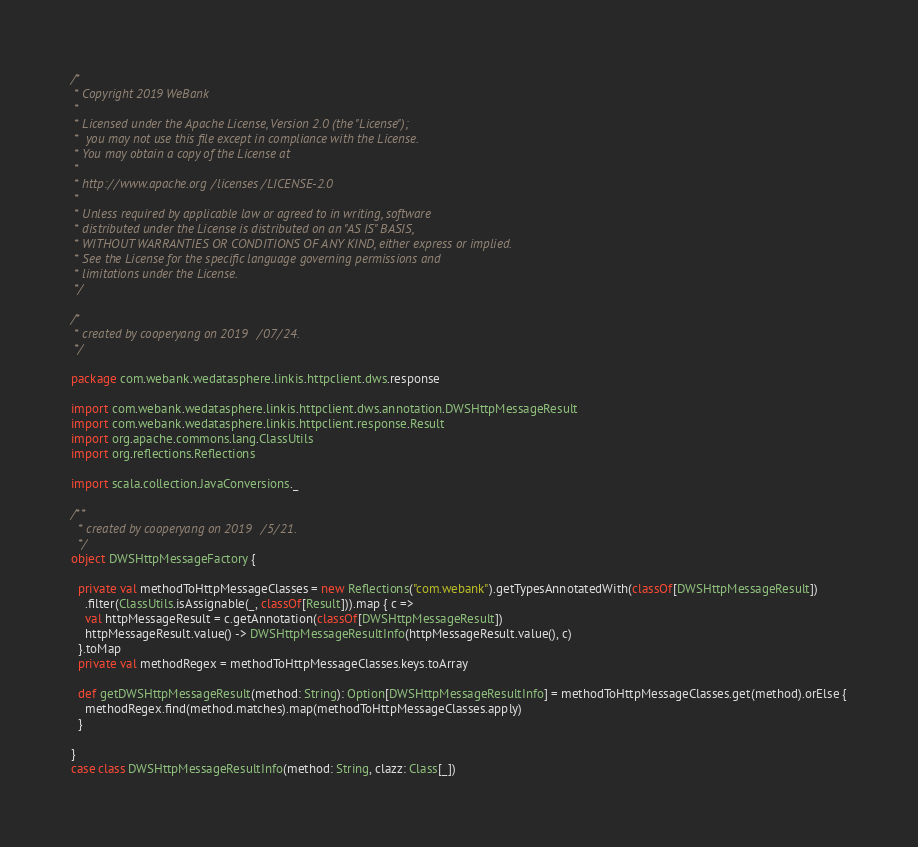<code> <loc_0><loc_0><loc_500><loc_500><_Scala_>/*
 * Copyright 2019 WeBank
 *
 * Licensed under the Apache License, Version 2.0 (the "License");
 *  you may not use this file except in compliance with the License.
 * You may obtain a copy of the License at
 *
 * http://www.apache.org/licenses/LICENSE-2.0
 *
 * Unless required by applicable law or agreed to in writing, software
 * distributed under the License is distributed on an "AS IS" BASIS,
 * WITHOUT WARRANTIES OR CONDITIONS OF ANY KIND, either express or implied.
 * See the License for the specific language governing permissions and
 * limitations under the License.
 */

/*
 * created by cooperyang on 2019/07/24.
 */

package com.webank.wedatasphere.linkis.httpclient.dws.response

import com.webank.wedatasphere.linkis.httpclient.dws.annotation.DWSHttpMessageResult
import com.webank.wedatasphere.linkis.httpclient.response.Result
import org.apache.commons.lang.ClassUtils
import org.reflections.Reflections

import scala.collection.JavaConversions._

/**
  * created by cooperyang on 2019/5/21.
  */
object DWSHttpMessageFactory {

  private val methodToHttpMessageClasses = new Reflections("com.webank").getTypesAnnotatedWith(classOf[DWSHttpMessageResult])
    .filter(ClassUtils.isAssignable(_, classOf[Result])).map { c =>
    val httpMessageResult = c.getAnnotation(classOf[DWSHttpMessageResult])
    httpMessageResult.value() -> DWSHttpMessageResultInfo(httpMessageResult.value(), c)
  }.toMap
  private val methodRegex = methodToHttpMessageClasses.keys.toArray

  def getDWSHttpMessageResult(method: String): Option[DWSHttpMessageResultInfo] = methodToHttpMessageClasses.get(method).orElse {
    methodRegex.find(method.matches).map(methodToHttpMessageClasses.apply)
  }

}
case class DWSHttpMessageResultInfo(method: String, clazz: Class[_])</code> 